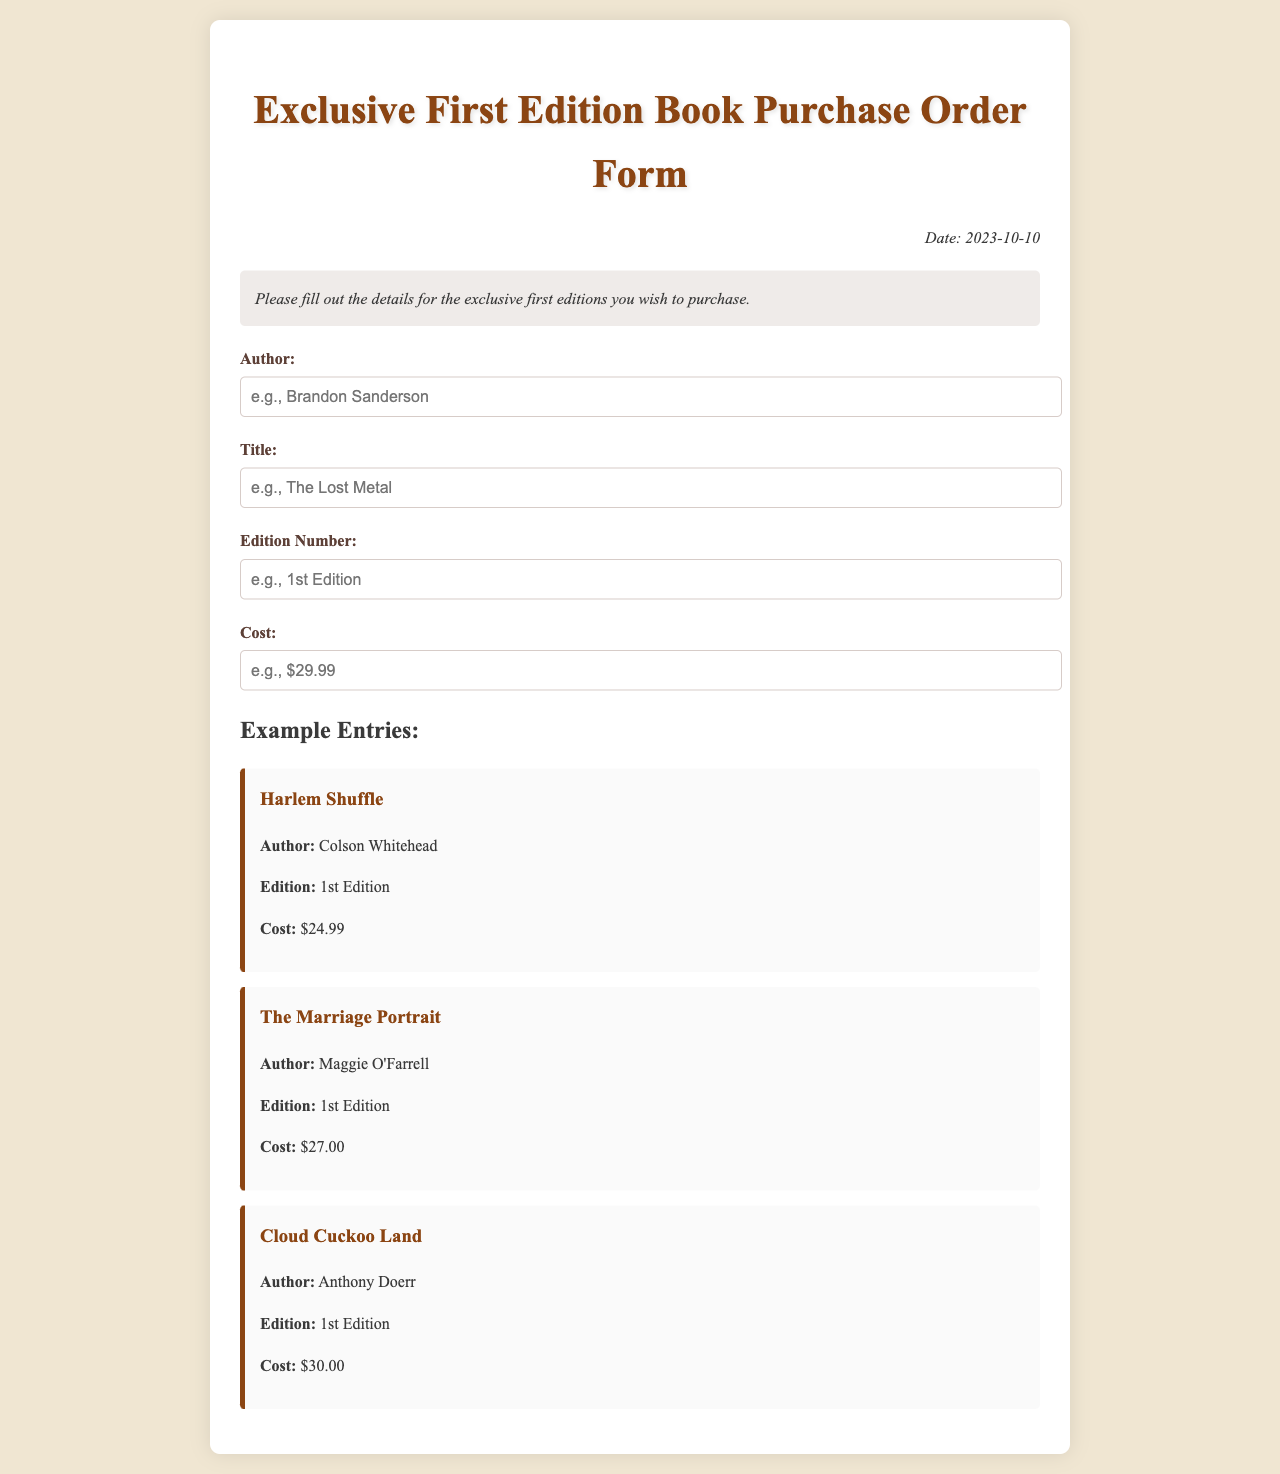What is the date of the form? The date is specified in the document as the date of the order form, located at the top right corner.
Answer: 2023-10-10 What is the title of the first example entry? The title is listed under the example entries section, specifically at the beginning of the first entry box.
Answer: Harlem Shuffle Who is the author of "The Marriage Portrait"? The author is mentioned directly under the title in the corresponding entry box.
Answer: Maggie O'Farrell What is the cost of the "Cloud Cuckoo Land"? The cost is mentioned in the entry box specifically for that title.
Answer: $30.00 What edition type is specified for all example entries? The edition type is consistent across the three example entries and is specified right after the author in each of the entry boxes.
Answer: 1st Edition How many example entries are provided in the document? The number of entries can be counted from the example entries section in the document.
Answer: 3 What is the background color of the document? The background color is defined in the style section of the document's code.
Answer: #f0e6d2 What form of submission is implied by the document? The document asks for details to be filled out, implying a submission for an order form.
Answer: Order form 